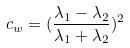<formula> <loc_0><loc_0><loc_500><loc_500>c _ { w } = ( \frac { \lambda _ { 1 } - \lambda _ { 2 } } { \lambda _ { 1 } + \lambda _ { 2 } } ) ^ { 2 }</formula> 